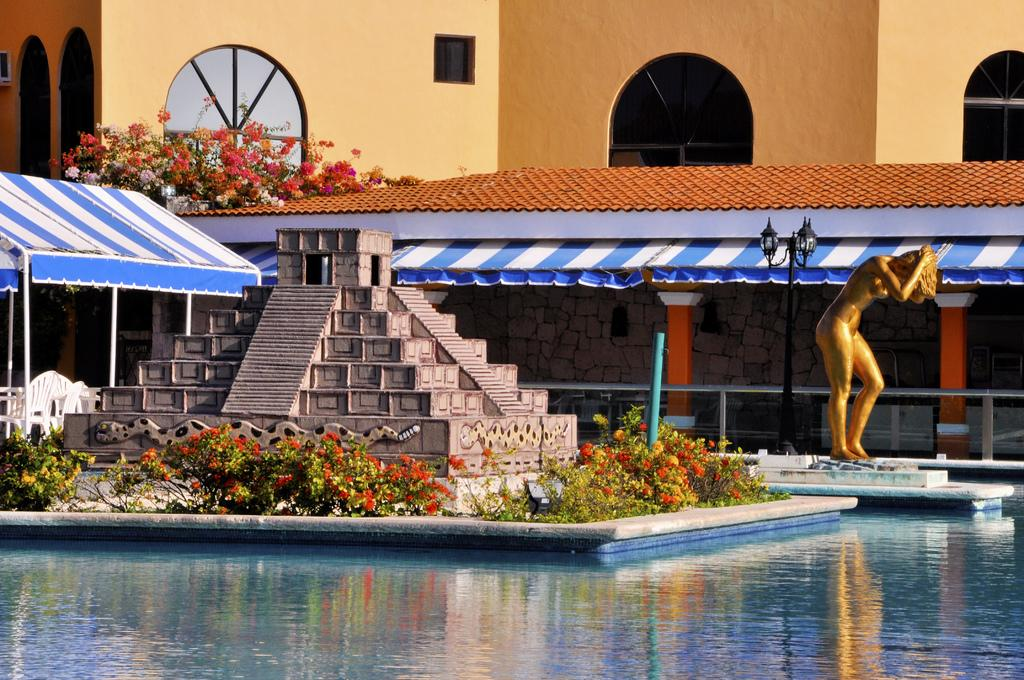What is the main feature in the image? There is a pool with water in the image. What can be seen behind the pool? There are plants with flowers behind the pool. Are there any other structures or objects in the image? Yes, there is a statue, a pole with a lamp, a tent, and a building wall with glass windows visible in the image. What is the name of the daughter playing near the pool in the image? There is no daughter present in the image; it only features a pool, plants with flowers, a statue, a pole with a lamp, a tent, and a building wall with glass windows. 